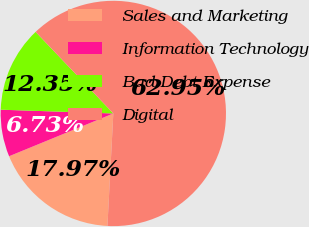Convert chart. <chart><loc_0><loc_0><loc_500><loc_500><pie_chart><fcel>Sales and Marketing<fcel>Information Technology<fcel>Bad Debt Expense<fcel>Digital<nl><fcel>17.97%<fcel>6.73%<fcel>12.35%<fcel>62.95%<nl></chart> 